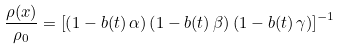<formula> <loc_0><loc_0><loc_500><loc_500>\frac { \rho ( { x } ) } { \rho _ { 0 } } = \left [ \left ( 1 - b ( t ) \, \alpha \right ) \left ( 1 - b ( t ) \, \beta \right ) \left ( 1 - b ( t ) \, \gamma \right ) \right ] ^ { - 1 }</formula> 